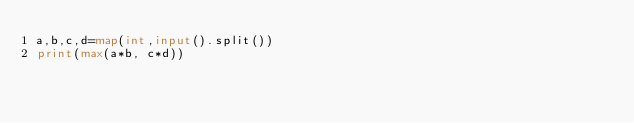<code> <loc_0><loc_0><loc_500><loc_500><_Python_>a,b,c,d=map(int,input().split())
print(max(a*b, c*d))</code> 